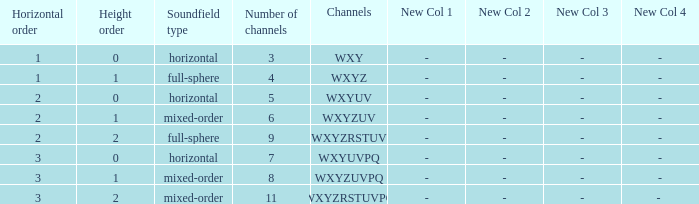If the channels is wxyzuv, what is the number of channels? 6.0. 